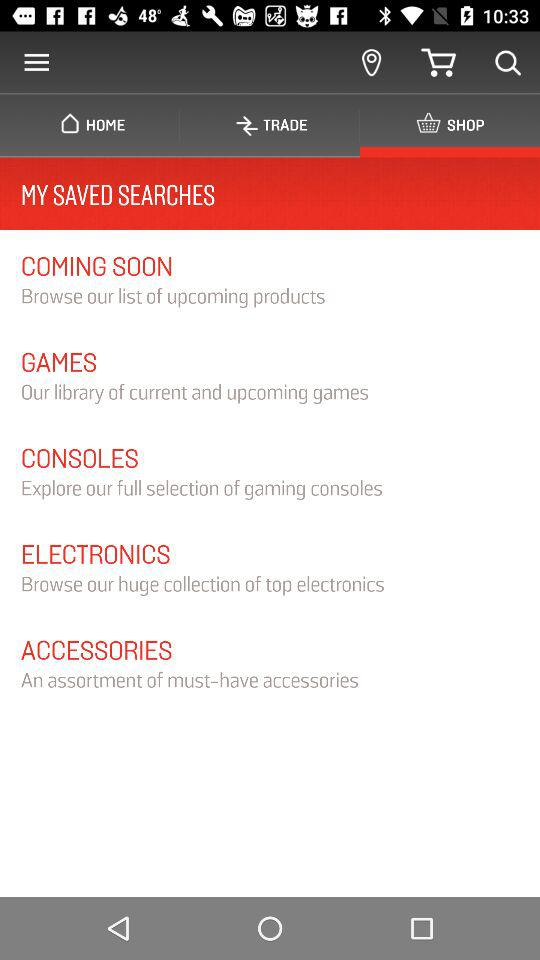Is there any item in the cart?
When the provided information is insufficient, respond with <no answer>. <no answer> 